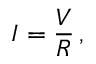Convert formula to latex. <formula><loc_0><loc_0><loc_500><loc_500>I = { \frac { V } { R } } \, ,</formula> 